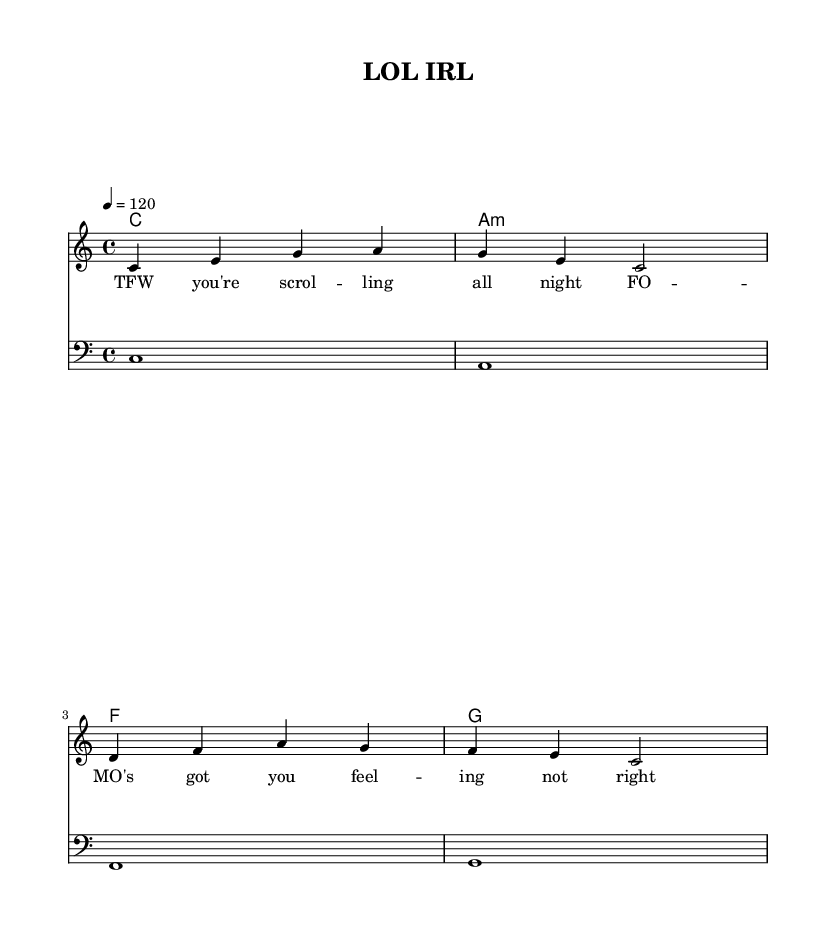What is the key signature of this music? The key signature is indicated at the beginning of the score. Looking at the \key section, it states "c \major," which means it has no sharps or flats.
Answer: C major What is the time signature of this music? The time signature is found in the \time section of the music code, which states "4/4." This means there are four beats per measure with a quarter note getting one beat.
Answer: 4/4 What is the tempo marking for this piece? The tempo marking is in the \tempo section, which states "4 = 120." This indicates the speed of the music, meaning there are 120 beats per minute.
Answer: 120 How many measures are in the melody section? The melody section has four measures, which can be counted through the groups of notes separated by the vertical lines in the music notation.
Answer: 4 What is the name of the title of the piece? The title is given in the \header section at the beginning of the score. It states "title = 'LOL IRL'." Hence, that is the name of the piece.
Answer: LOL IRL What is the first lyric line of the song? The first lyric line is found in the \lyricmode section. It states "TFW you're scrol -- ling all night," which indicates what is sung first.
Answer: TFW you're scrolling all night What chords are used in the harmony section? The harmony section consists of the chords listed under \harmonies. These are "c1," "a:m," "f," and "g." They indicate the chords played throughout the piece.
Answer: c1, a:m, f, g 